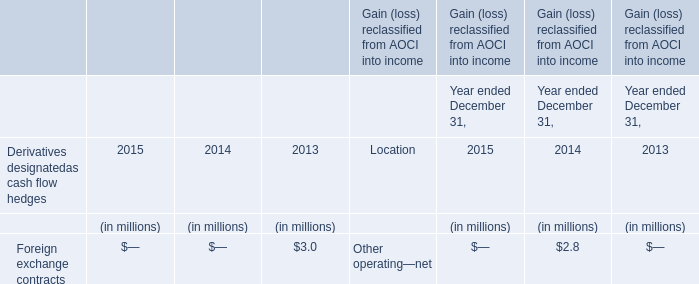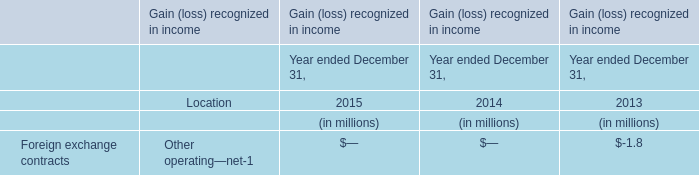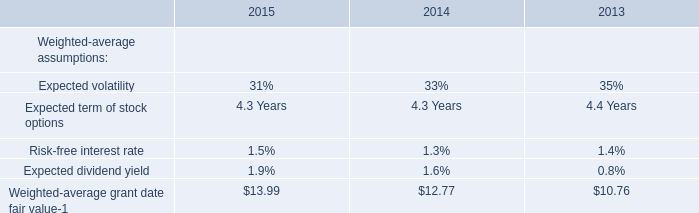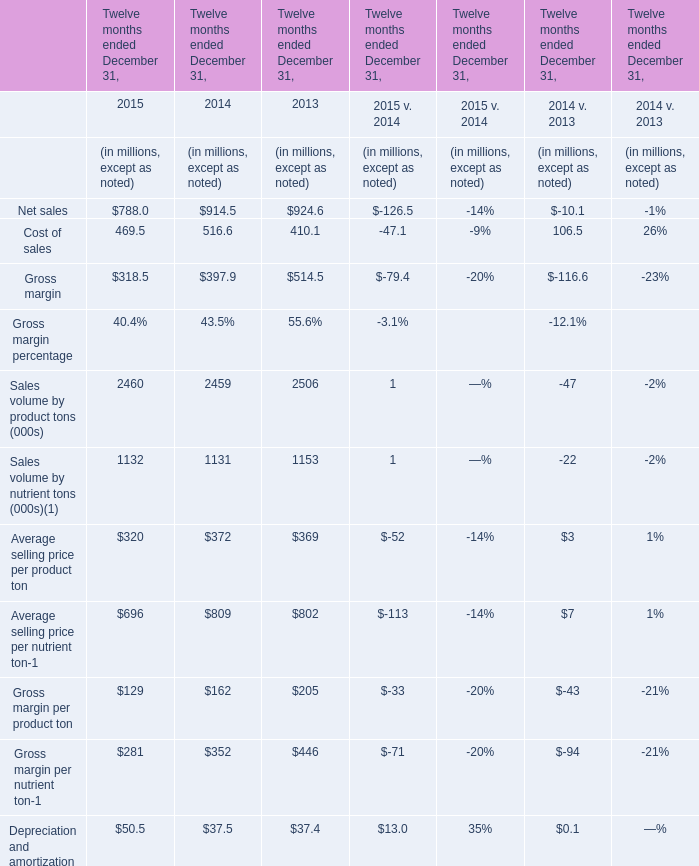What's the average of the Cost of sales in the years where Expected volatility is greater than 30 %? (in million) 
Computations: (((469.5 + 516.6) + 410.1) / 3)
Answer: 465.4. 